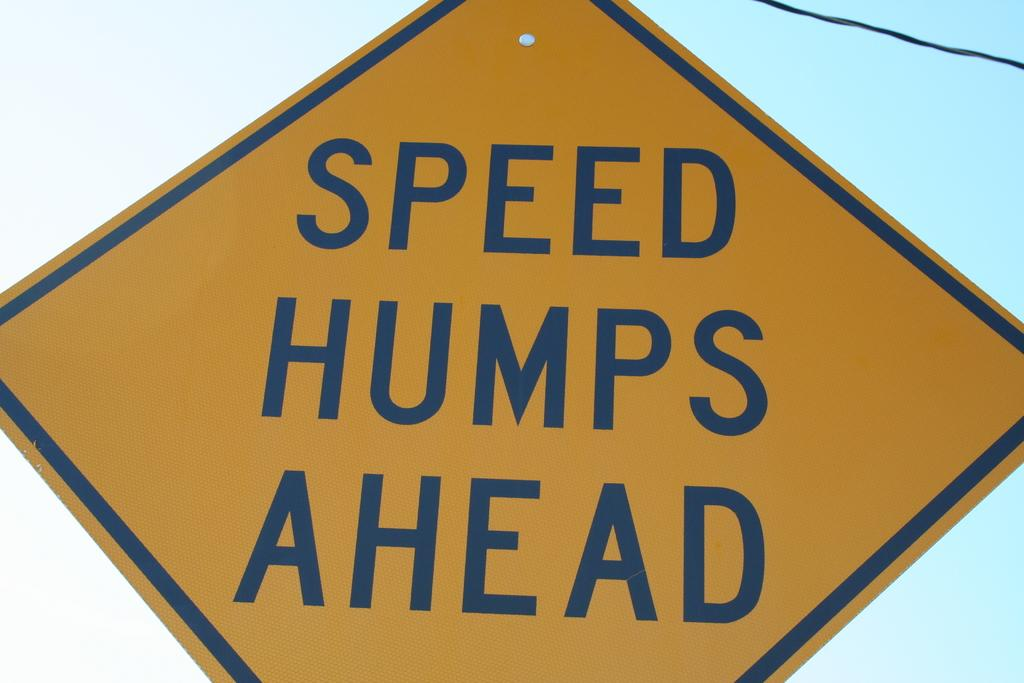Provide a one-sentence caption for the provided image. A road sign warning of speed bumps ahead. 